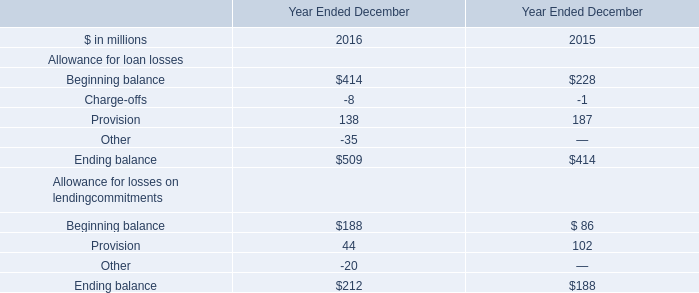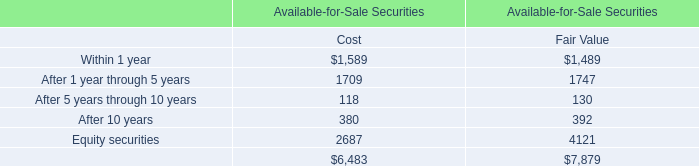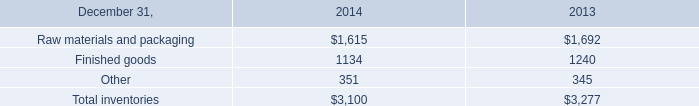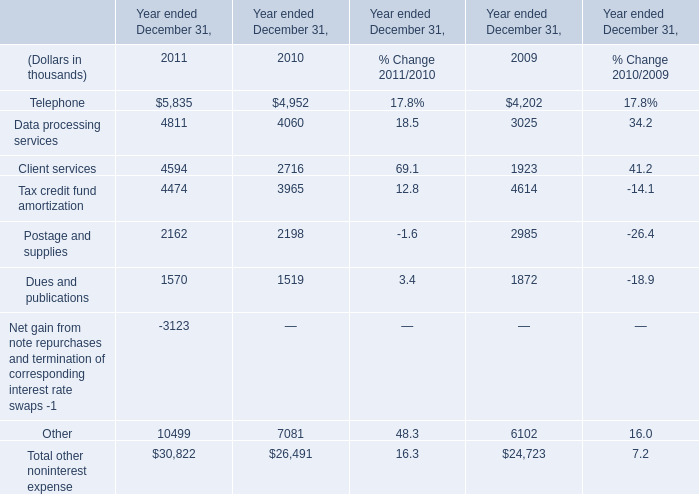what's the total amount of Finished goods of 2014, Client services of Year ended December 31, 2009, and Postage and supplies of Year ended December 31, 2010 ? 
Computations: ((1134.0 + 1923.0) + 2198.0)
Answer: 5255.0. 